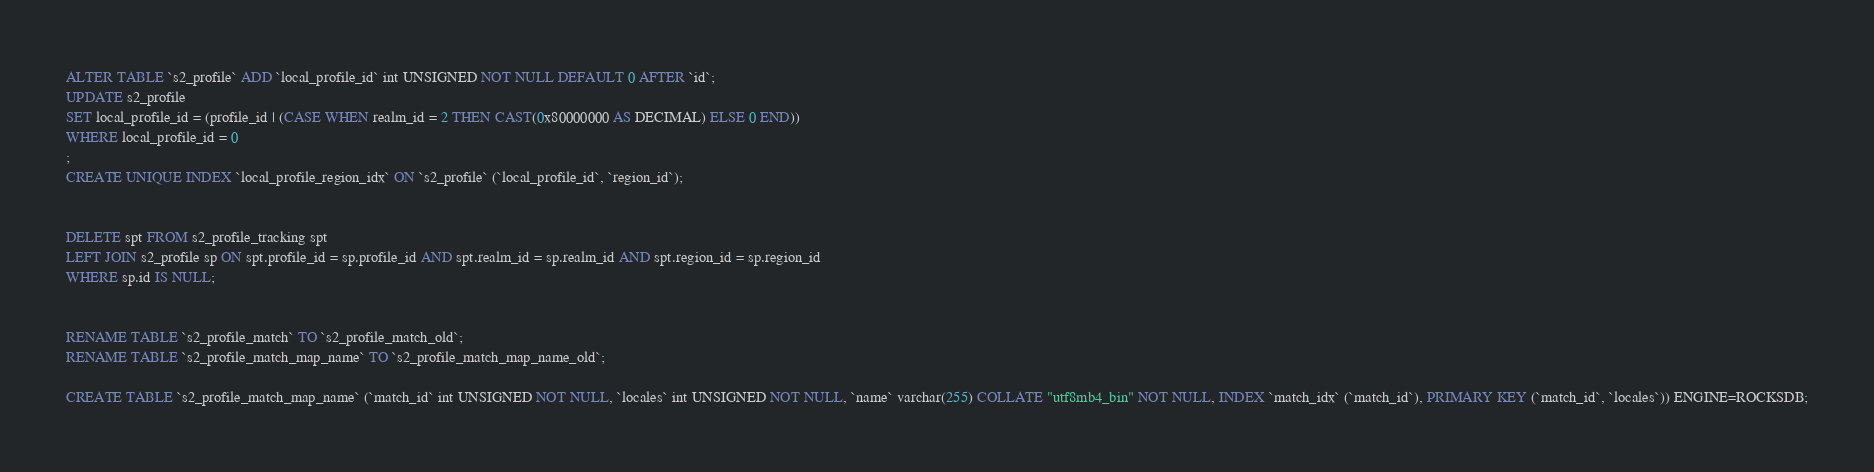<code> <loc_0><loc_0><loc_500><loc_500><_SQL_>ALTER TABLE `s2_profile` ADD `local_profile_id` int UNSIGNED NOT NULL DEFAULT 0 AFTER `id`;
UPDATE s2_profile
SET local_profile_id = (profile_id | (CASE WHEN realm_id = 2 THEN CAST(0x80000000 AS DECIMAL) ELSE 0 END))
WHERE local_profile_id = 0
;
CREATE UNIQUE INDEX `local_profile_region_idx` ON `s2_profile` (`local_profile_id`, `region_id`);


DELETE spt FROM s2_profile_tracking spt
LEFT JOIN s2_profile sp ON spt.profile_id = sp.profile_id AND spt.realm_id = sp.realm_id AND spt.region_id = sp.region_id
WHERE sp.id IS NULL;


RENAME TABLE `s2_profile_match` TO `s2_profile_match_old`;
RENAME TABLE `s2_profile_match_map_name` TO `s2_profile_match_map_name_old`;

CREATE TABLE `s2_profile_match_map_name` (`match_id` int UNSIGNED NOT NULL, `locales` int UNSIGNED NOT NULL, `name` varchar(255) COLLATE "utf8mb4_bin" NOT NULL, INDEX `match_idx` (`match_id`), PRIMARY KEY (`match_id`, `locales`)) ENGINE=ROCKSDB;</code> 